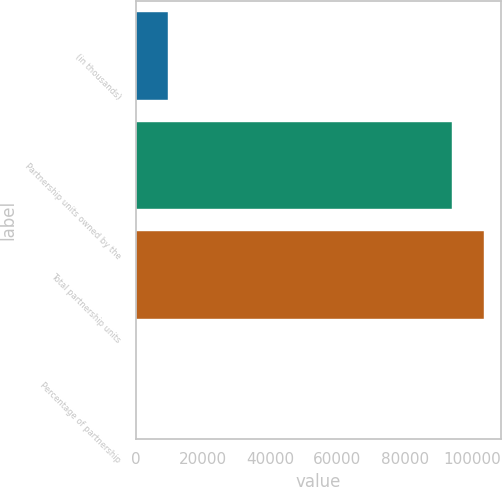Convert chart to OTSL. <chart><loc_0><loc_0><loc_500><loc_500><bar_chart><fcel>(in thousands)<fcel>Partnership units owned by the<fcel>Total partnership units<fcel>Percentage of partnership<nl><fcel>9516.02<fcel>94108<fcel>103524<fcel>99.8<nl></chart> 